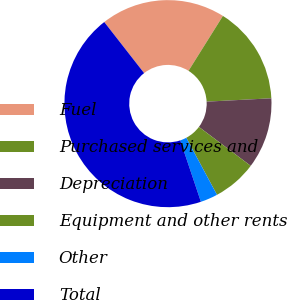<chart> <loc_0><loc_0><loc_500><loc_500><pie_chart><fcel>Fuel<fcel>Purchased services and<fcel>Depreciation<fcel>Equipment and other rents<fcel>Other<fcel>Total<nl><fcel>19.46%<fcel>15.27%<fcel>11.08%<fcel>6.89%<fcel>2.7%<fcel>44.61%<nl></chart> 